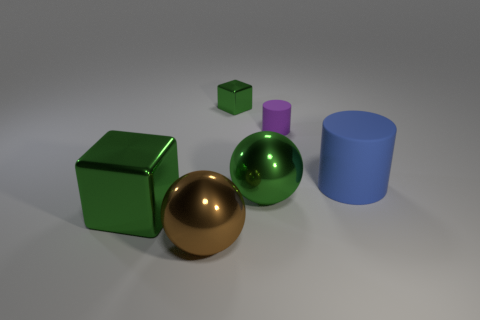How could you use these objects to explain geometry to a child? These objects could be excellent visual aids for teaching basic geometric shapes. The spheres can represent round, 3D shapes without edges, the cubes can illustrate shapes with equal-length sides and 90-degree corners, and the cylinders can show a shape with circular bases connected by a curved surface. Together, they can be used to convey the concepts of volume, surface area, and the difference between 2D and 3D shapes. 